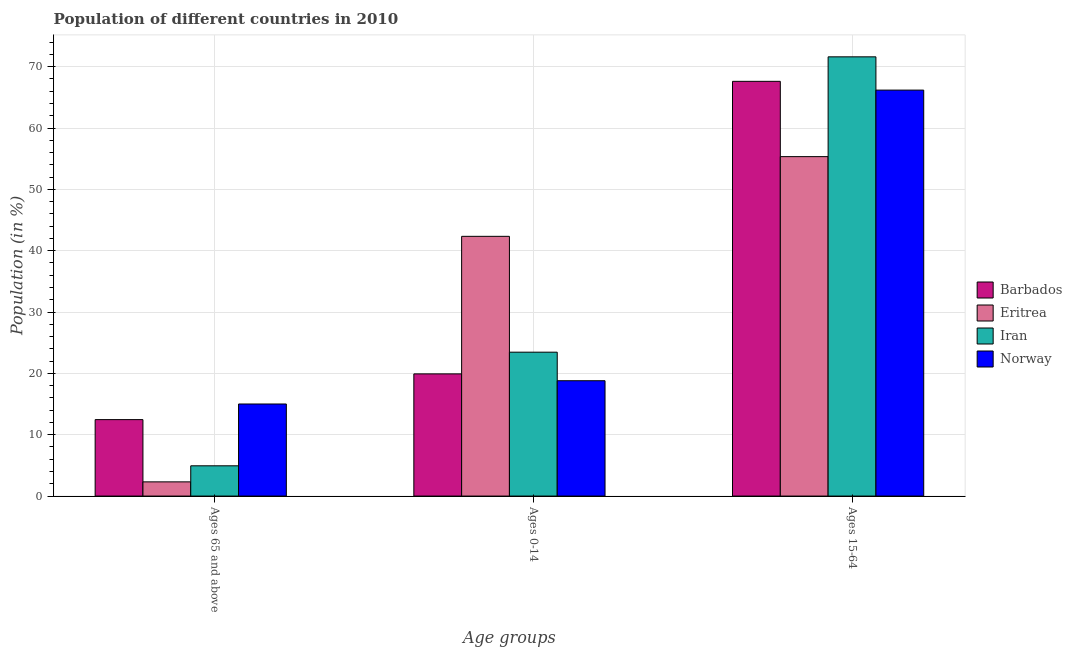How many groups of bars are there?
Provide a short and direct response. 3. Are the number of bars on each tick of the X-axis equal?
Give a very brief answer. Yes. How many bars are there on the 2nd tick from the left?
Offer a very short reply. 4. How many bars are there on the 2nd tick from the right?
Give a very brief answer. 4. What is the label of the 2nd group of bars from the left?
Ensure brevity in your answer.  Ages 0-14. What is the percentage of population within the age-group 15-64 in Eritrea?
Offer a very short reply. 55.34. Across all countries, what is the maximum percentage of population within the age-group 15-64?
Your answer should be very brief. 71.61. Across all countries, what is the minimum percentage of population within the age-group of 65 and above?
Give a very brief answer. 2.32. In which country was the percentage of population within the age-group 0-14 maximum?
Make the answer very short. Eritrea. What is the total percentage of population within the age-group of 65 and above in the graph?
Give a very brief answer. 34.72. What is the difference between the percentage of population within the age-group 0-14 in Iran and that in Barbados?
Provide a succinct answer. 3.54. What is the difference between the percentage of population within the age-group 15-64 in Eritrea and the percentage of population within the age-group 0-14 in Norway?
Make the answer very short. 36.54. What is the average percentage of population within the age-group 15-64 per country?
Provide a succinct answer. 65.19. What is the difference between the percentage of population within the age-group 15-64 and percentage of population within the age-group 0-14 in Iran?
Provide a short and direct response. 48.15. What is the ratio of the percentage of population within the age-group of 65 and above in Iran to that in Barbados?
Give a very brief answer. 0.4. Is the percentage of population within the age-group 0-14 in Iran less than that in Barbados?
Keep it short and to the point. No. What is the difference between the highest and the second highest percentage of population within the age-group 0-14?
Provide a short and direct response. 18.89. What is the difference between the highest and the lowest percentage of population within the age-group 15-64?
Your answer should be very brief. 16.27. What does the 4th bar from the left in Ages 0-14 represents?
Offer a very short reply. Norway. What does the 3rd bar from the right in Ages 0-14 represents?
Provide a succinct answer. Eritrea. Is it the case that in every country, the sum of the percentage of population within the age-group of 65 and above and percentage of population within the age-group 0-14 is greater than the percentage of population within the age-group 15-64?
Offer a terse response. No. How many bars are there?
Make the answer very short. 12. Are all the bars in the graph horizontal?
Offer a terse response. No. How many countries are there in the graph?
Offer a very short reply. 4. Are the values on the major ticks of Y-axis written in scientific E-notation?
Keep it short and to the point. No. Does the graph contain grids?
Offer a very short reply. Yes. How many legend labels are there?
Provide a succinct answer. 4. What is the title of the graph?
Your response must be concise. Population of different countries in 2010. Does "Comoros" appear as one of the legend labels in the graph?
Provide a succinct answer. No. What is the label or title of the X-axis?
Ensure brevity in your answer.  Age groups. What is the Population (in %) in Barbados in Ages 65 and above?
Your answer should be compact. 12.46. What is the Population (in %) of Eritrea in Ages 65 and above?
Keep it short and to the point. 2.32. What is the Population (in %) of Iran in Ages 65 and above?
Your response must be concise. 4.93. What is the Population (in %) of Norway in Ages 65 and above?
Provide a short and direct response. 15.01. What is the Population (in %) in Barbados in Ages 0-14?
Provide a short and direct response. 19.92. What is the Population (in %) in Eritrea in Ages 0-14?
Provide a succinct answer. 42.35. What is the Population (in %) of Iran in Ages 0-14?
Keep it short and to the point. 23.46. What is the Population (in %) of Norway in Ages 0-14?
Your answer should be very brief. 18.8. What is the Population (in %) of Barbados in Ages 15-64?
Your answer should be compact. 67.61. What is the Population (in %) of Eritrea in Ages 15-64?
Ensure brevity in your answer.  55.34. What is the Population (in %) of Iran in Ages 15-64?
Offer a very short reply. 71.61. What is the Population (in %) of Norway in Ages 15-64?
Offer a terse response. 66.19. Across all Age groups, what is the maximum Population (in %) in Barbados?
Your response must be concise. 67.61. Across all Age groups, what is the maximum Population (in %) in Eritrea?
Your response must be concise. 55.34. Across all Age groups, what is the maximum Population (in %) of Iran?
Ensure brevity in your answer.  71.61. Across all Age groups, what is the maximum Population (in %) of Norway?
Provide a short and direct response. 66.19. Across all Age groups, what is the minimum Population (in %) in Barbados?
Your answer should be very brief. 12.46. Across all Age groups, what is the minimum Population (in %) in Eritrea?
Your answer should be very brief. 2.32. Across all Age groups, what is the minimum Population (in %) of Iran?
Keep it short and to the point. 4.93. Across all Age groups, what is the minimum Population (in %) of Norway?
Make the answer very short. 15.01. What is the total Population (in %) in Barbados in the graph?
Provide a succinct answer. 100. What is the total Population (in %) of Eritrea in the graph?
Your answer should be compact. 100. What is the total Population (in %) of Iran in the graph?
Offer a terse response. 100. What is the total Population (in %) in Norway in the graph?
Offer a terse response. 100. What is the difference between the Population (in %) in Barbados in Ages 65 and above and that in Ages 0-14?
Your answer should be compact. -7.46. What is the difference between the Population (in %) in Eritrea in Ages 65 and above and that in Ages 0-14?
Offer a terse response. -40.03. What is the difference between the Population (in %) in Iran in Ages 65 and above and that in Ages 0-14?
Offer a very short reply. -18.53. What is the difference between the Population (in %) of Norway in Ages 65 and above and that in Ages 0-14?
Provide a succinct answer. -3.79. What is the difference between the Population (in %) in Barbados in Ages 65 and above and that in Ages 15-64?
Provide a short and direct response. -55.15. What is the difference between the Population (in %) of Eritrea in Ages 65 and above and that in Ages 15-64?
Offer a very short reply. -53.02. What is the difference between the Population (in %) in Iran in Ages 65 and above and that in Ages 15-64?
Your answer should be very brief. -66.68. What is the difference between the Population (in %) in Norway in Ages 65 and above and that in Ages 15-64?
Provide a short and direct response. -51.17. What is the difference between the Population (in %) of Barbados in Ages 0-14 and that in Ages 15-64?
Ensure brevity in your answer.  -47.69. What is the difference between the Population (in %) in Eritrea in Ages 0-14 and that in Ages 15-64?
Ensure brevity in your answer.  -12.99. What is the difference between the Population (in %) in Iran in Ages 0-14 and that in Ages 15-64?
Give a very brief answer. -48.15. What is the difference between the Population (in %) in Norway in Ages 0-14 and that in Ages 15-64?
Provide a succinct answer. -47.38. What is the difference between the Population (in %) of Barbados in Ages 65 and above and the Population (in %) of Eritrea in Ages 0-14?
Keep it short and to the point. -29.88. What is the difference between the Population (in %) in Barbados in Ages 65 and above and the Population (in %) in Iran in Ages 0-14?
Ensure brevity in your answer.  -10.99. What is the difference between the Population (in %) of Barbados in Ages 65 and above and the Population (in %) of Norway in Ages 0-14?
Offer a very short reply. -6.34. What is the difference between the Population (in %) of Eritrea in Ages 65 and above and the Population (in %) of Iran in Ages 0-14?
Your answer should be compact. -21.14. What is the difference between the Population (in %) in Eritrea in Ages 65 and above and the Population (in %) in Norway in Ages 0-14?
Your response must be concise. -16.49. What is the difference between the Population (in %) in Iran in Ages 65 and above and the Population (in %) in Norway in Ages 0-14?
Provide a succinct answer. -13.87. What is the difference between the Population (in %) of Barbados in Ages 65 and above and the Population (in %) of Eritrea in Ages 15-64?
Ensure brevity in your answer.  -42.87. What is the difference between the Population (in %) of Barbados in Ages 65 and above and the Population (in %) of Iran in Ages 15-64?
Ensure brevity in your answer.  -59.14. What is the difference between the Population (in %) in Barbados in Ages 65 and above and the Population (in %) in Norway in Ages 15-64?
Make the answer very short. -53.72. What is the difference between the Population (in %) of Eritrea in Ages 65 and above and the Population (in %) of Iran in Ages 15-64?
Ensure brevity in your answer.  -69.29. What is the difference between the Population (in %) in Eritrea in Ages 65 and above and the Population (in %) in Norway in Ages 15-64?
Your response must be concise. -63.87. What is the difference between the Population (in %) in Iran in Ages 65 and above and the Population (in %) in Norway in Ages 15-64?
Your answer should be compact. -61.25. What is the difference between the Population (in %) of Barbados in Ages 0-14 and the Population (in %) of Eritrea in Ages 15-64?
Your answer should be compact. -35.42. What is the difference between the Population (in %) of Barbados in Ages 0-14 and the Population (in %) of Iran in Ages 15-64?
Your answer should be very brief. -51.69. What is the difference between the Population (in %) of Barbados in Ages 0-14 and the Population (in %) of Norway in Ages 15-64?
Your response must be concise. -46.26. What is the difference between the Population (in %) of Eritrea in Ages 0-14 and the Population (in %) of Iran in Ages 15-64?
Offer a terse response. -29.26. What is the difference between the Population (in %) in Eritrea in Ages 0-14 and the Population (in %) in Norway in Ages 15-64?
Keep it short and to the point. -23.84. What is the difference between the Population (in %) in Iran in Ages 0-14 and the Population (in %) in Norway in Ages 15-64?
Make the answer very short. -42.73. What is the average Population (in %) in Barbados per Age groups?
Your answer should be very brief. 33.33. What is the average Population (in %) of Eritrea per Age groups?
Offer a very short reply. 33.33. What is the average Population (in %) in Iran per Age groups?
Your answer should be very brief. 33.33. What is the average Population (in %) of Norway per Age groups?
Your response must be concise. 33.33. What is the difference between the Population (in %) in Barbados and Population (in %) in Eritrea in Ages 65 and above?
Make the answer very short. 10.15. What is the difference between the Population (in %) in Barbados and Population (in %) in Iran in Ages 65 and above?
Keep it short and to the point. 7.53. What is the difference between the Population (in %) in Barbados and Population (in %) in Norway in Ages 65 and above?
Provide a succinct answer. -2.55. What is the difference between the Population (in %) in Eritrea and Population (in %) in Iran in Ages 65 and above?
Give a very brief answer. -2.62. What is the difference between the Population (in %) of Eritrea and Population (in %) of Norway in Ages 65 and above?
Offer a very short reply. -12.7. What is the difference between the Population (in %) of Iran and Population (in %) of Norway in Ages 65 and above?
Keep it short and to the point. -10.08. What is the difference between the Population (in %) in Barbados and Population (in %) in Eritrea in Ages 0-14?
Your answer should be compact. -22.42. What is the difference between the Population (in %) in Barbados and Population (in %) in Iran in Ages 0-14?
Make the answer very short. -3.54. What is the difference between the Population (in %) in Barbados and Population (in %) in Norway in Ages 0-14?
Your answer should be compact. 1.12. What is the difference between the Population (in %) in Eritrea and Population (in %) in Iran in Ages 0-14?
Your answer should be compact. 18.89. What is the difference between the Population (in %) of Eritrea and Population (in %) of Norway in Ages 0-14?
Your answer should be very brief. 23.54. What is the difference between the Population (in %) in Iran and Population (in %) in Norway in Ages 0-14?
Provide a short and direct response. 4.66. What is the difference between the Population (in %) in Barbados and Population (in %) in Eritrea in Ages 15-64?
Your answer should be very brief. 12.28. What is the difference between the Population (in %) of Barbados and Population (in %) of Iran in Ages 15-64?
Provide a succinct answer. -3.99. What is the difference between the Population (in %) in Barbados and Population (in %) in Norway in Ages 15-64?
Offer a terse response. 1.43. What is the difference between the Population (in %) in Eritrea and Population (in %) in Iran in Ages 15-64?
Your response must be concise. -16.27. What is the difference between the Population (in %) in Eritrea and Population (in %) in Norway in Ages 15-64?
Provide a succinct answer. -10.85. What is the difference between the Population (in %) in Iran and Population (in %) in Norway in Ages 15-64?
Offer a very short reply. 5.42. What is the ratio of the Population (in %) in Barbados in Ages 65 and above to that in Ages 0-14?
Your answer should be compact. 0.63. What is the ratio of the Population (in %) of Eritrea in Ages 65 and above to that in Ages 0-14?
Provide a short and direct response. 0.05. What is the ratio of the Population (in %) of Iran in Ages 65 and above to that in Ages 0-14?
Provide a succinct answer. 0.21. What is the ratio of the Population (in %) in Norway in Ages 65 and above to that in Ages 0-14?
Offer a very short reply. 0.8. What is the ratio of the Population (in %) in Barbados in Ages 65 and above to that in Ages 15-64?
Offer a very short reply. 0.18. What is the ratio of the Population (in %) of Eritrea in Ages 65 and above to that in Ages 15-64?
Give a very brief answer. 0.04. What is the ratio of the Population (in %) of Iran in Ages 65 and above to that in Ages 15-64?
Ensure brevity in your answer.  0.07. What is the ratio of the Population (in %) of Norway in Ages 65 and above to that in Ages 15-64?
Keep it short and to the point. 0.23. What is the ratio of the Population (in %) of Barbados in Ages 0-14 to that in Ages 15-64?
Offer a very short reply. 0.29. What is the ratio of the Population (in %) in Eritrea in Ages 0-14 to that in Ages 15-64?
Your answer should be compact. 0.77. What is the ratio of the Population (in %) of Iran in Ages 0-14 to that in Ages 15-64?
Provide a succinct answer. 0.33. What is the ratio of the Population (in %) of Norway in Ages 0-14 to that in Ages 15-64?
Make the answer very short. 0.28. What is the difference between the highest and the second highest Population (in %) of Barbados?
Your answer should be very brief. 47.69. What is the difference between the highest and the second highest Population (in %) in Eritrea?
Ensure brevity in your answer.  12.99. What is the difference between the highest and the second highest Population (in %) in Iran?
Ensure brevity in your answer.  48.15. What is the difference between the highest and the second highest Population (in %) of Norway?
Give a very brief answer. 47.38. What is the difference between the highest and the lowest Population (in %) of Barbados?
Give a very brief answer. 55.15. What is the difference between the highest and the lowest Population (in %) in Eritrea?
Provide a short and direct response. 53.02. What is the difference between the highest and the lowest Population (in %) of Iran?
Your answer should be very brief. 66.68. What is the difference between the highest and the lowest Population (in %) in Norway?
Your answer should be compact. 51.17. 